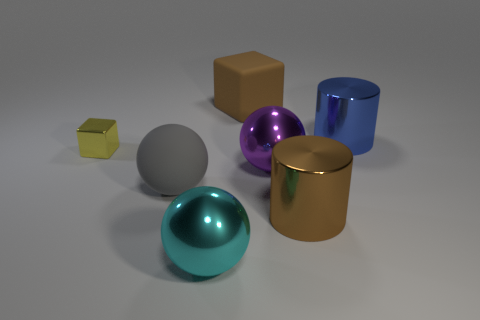Subtract all gray rubber balls. How many balls are left? 2 Add 2 small cyan rubber cubes. How many objects exist? 9 Subtract all yellow blocks. How many blocks are left? 1 Subtract 2 balls. How many balls are left? 1 Subtract 0 red balls. How many objects are left? 7 Subtract all spheres. How many objects are left? 4 Subtract all blue cubes. Subtract all purple cylinders. How many cubes are left? 2 Subtract all gray balls. How many red cylinders are left? 0 Subtract all gray things. Subtract all large cyan metal spheres. How many objects are left? 5 Add 6 cyan metallic spheres. How many cyan metallic spheres are left? 7 